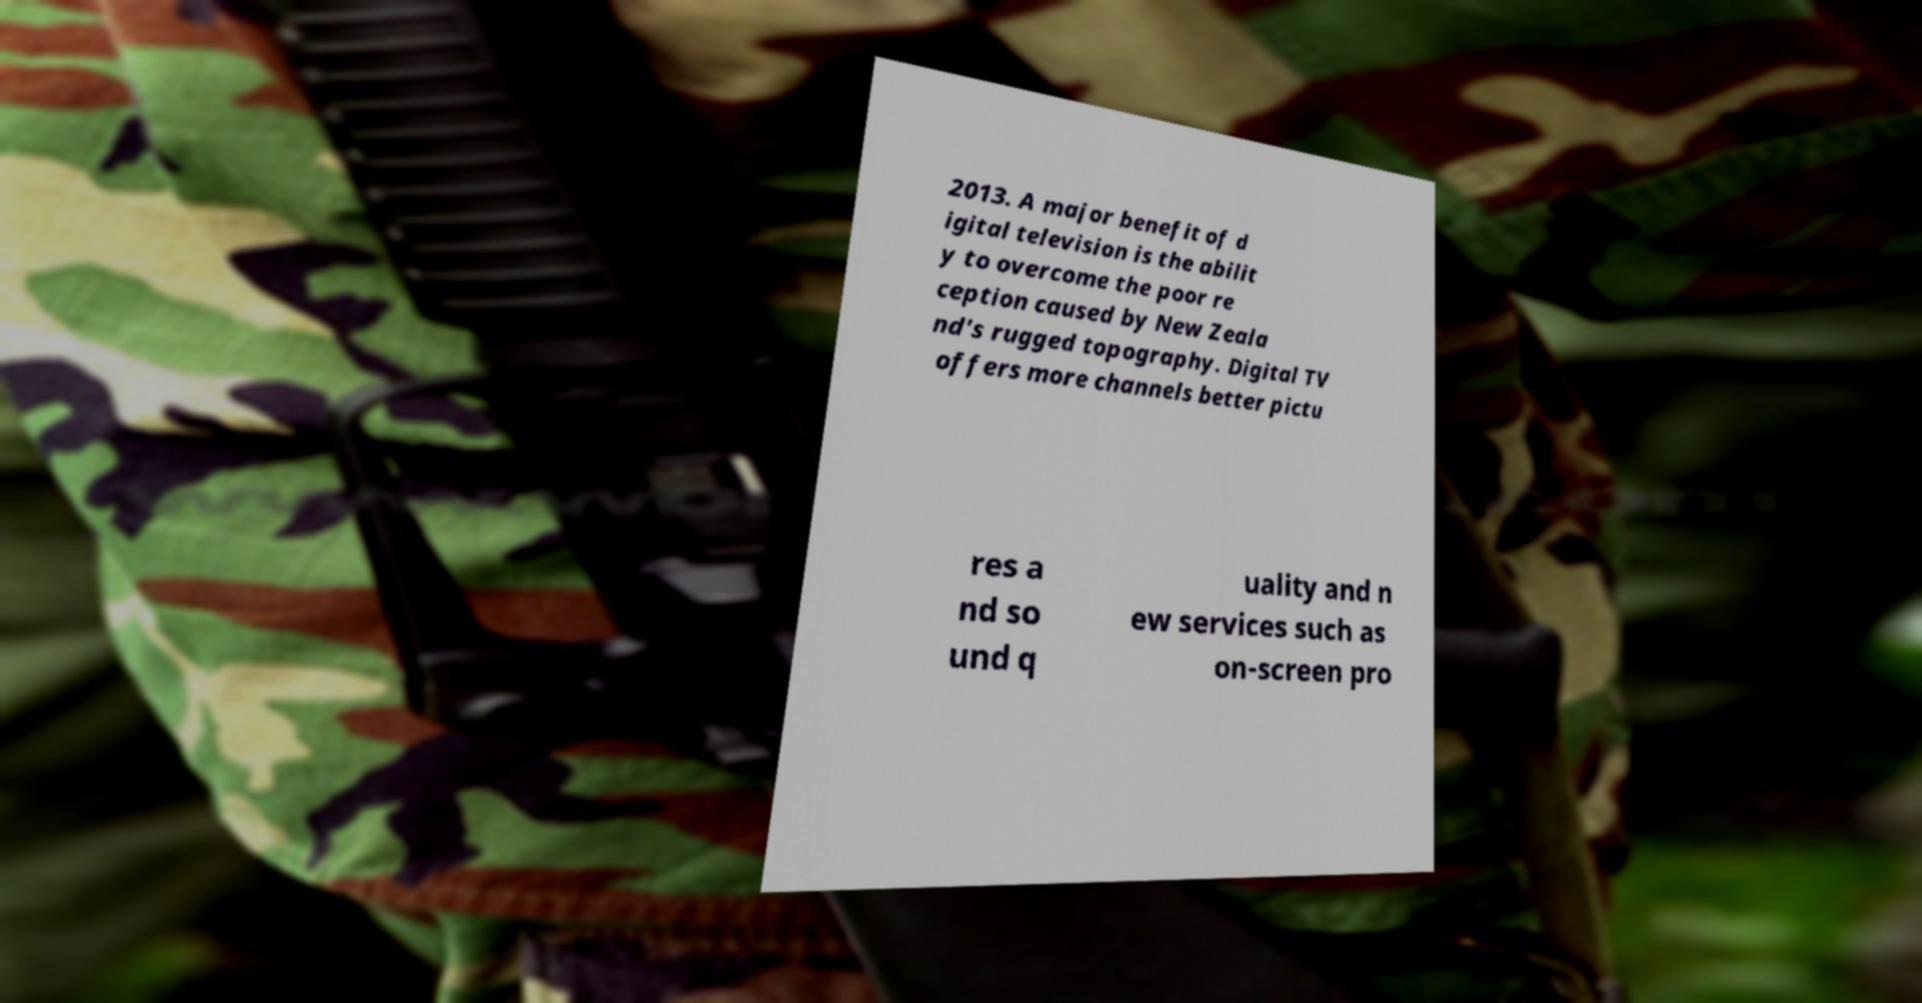Could you assist in decoding the text presented in this image and type it out clearly? 2013. A major benefit of d igital television is the abilit y to overcome the poor re ception caused by New Zeala nd's rugged topography. Digital TV offers more channels better pictu res a nd so und q uality and n ew services such as on-screen pro 